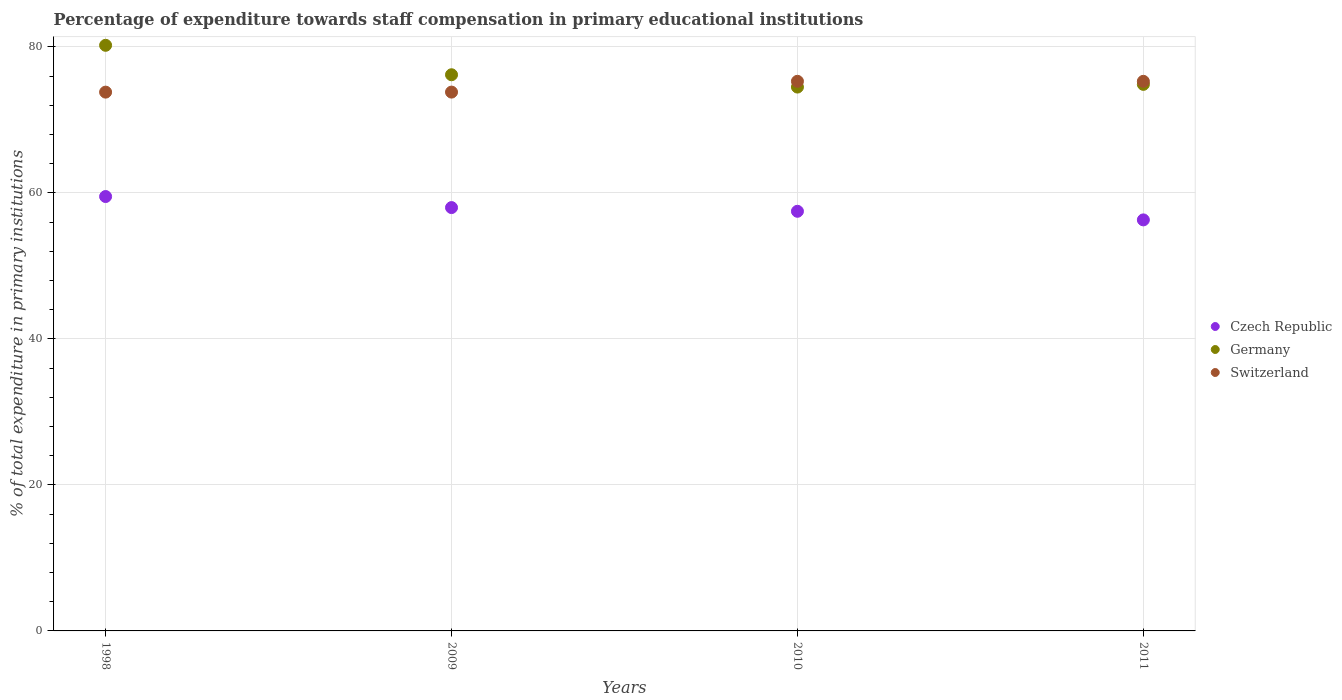What is the percentage of expenditure towards staff compensation in Czech Republic in 2009?
Your response must be concise. 57.99. Across all years, what is the maximum percentage of expenditure towards staff compensation in Czech Republic?
Your answer should be very brief. 59.51. Across all years, what is the minimum percentage of expenditure towards staff compensation in Germany?
Your answer should be very brief. 74.5. In which year was the percentage of expenditure towards staff compensation in Germany minimum?
Your answer should be very brief. 2010. What is the total percentage of expenditure towards staff compensation in Germany in the graph?
Offer a terse response. 305.79. What is the difference between the percentage of expenditure towards staff compensation in Switzerland in 1998 and that in 2011?
Provide a succinct answer. -1.48. What is the difference between the percentage of expenditure towards staff compensation in Czech Republic in 2011 and the percentage of expenditure towards staff compensation in Germany in 2009?
Your answer should be compact. -19.88. What is the average percentage of expenditure towards staff compensation in Czech Republic per year?
Give a very brief answer. 57.82. In the year 2011, what is the difference between the percentage of expenditure towards staff compensation in Czech Republic and percentage of expenditure towards staff compensation in Germany?
Offer a very short reply. -18.57. In how many years, is the percentage of expenditure towards staff compensation in Switzerland greater than 8 %?
Keep it short and to the point. 4. What is the ratio of the percentage of expenditure towards staff compensation in Czech Republic in 1998 to that in 2009?
Offer a very short reply. 1.03. Is the difference between the percentage of expenditure towards staff compensation in Czech Republic in 1998 and 2011 greater than the difference between the percentage of expenditure towards staff compensation in Germany in 1998 and 2011?
Offer a terse response. No. What is the difference between the highest and the second highest percentage of expenditure towards staff compensation in Germany?
Your answer should be very brief. 4.03. What is the difference between the highest and the lowest percentage of expenditure towards staff compensation in Czech Republic?
Give a very brief answer. 3.2. Is the percentage of expenditure towards staff compensation in Germany strictly less than the percentage of expenditure towards staff compensation in Czech Republic over the years?
Offer a terse response. No. How many dotlines are there?
Your response must be concise. 3. What is the difference between two consecutive major ticks on the Y-axis?
Offer a very short reply. 20. Are the values on the major ticks of Y-axis written in scientific E-notation?
Your answer should be very brief. No. Does the graph contain any zero values?
Ensure brevity in your answer.  No. How many legend labels are there?
Make the answer very short. 3. How are the legend labels stacked?
Your answer should be very brief. Vertical. What is the title of the graph?
Offer a terse response. Percentage of expenditure towards staff compensation in primary educational institutions. What is the label or title of the Y-axis?
Ensure brevity in your answer.  % of total expenditure in primary institutions. What is the % of total expenditure in primary institutions in Czech Republic in 1998?
Your response must be concise. 59.51. What is the % of total expenditure in primary institutions of Germany in 1998?
Provide a short and direct response. 80.22. What is the % of total expenditure in primary institutions of Switzerland in 1998?
Give a very brief answer. 73.81. What is the % of total expenditure in primary institutions of Czech Republic in 2009?
Ensure brevity in your answer.  57.99. What is the % of total expenditure in primary institutions of Germany in 2009?
Offer a terse response. 76.19. What is the % of total expenditure in primary institutions in Switzerland in 2009?
Give a very brief answer. 73.81. What is the % of total expenditure in primary institutions in Czech Republic in 2010?
Offer a very short reply. 57.49. What is the % of total expenditure in primary institutions in Germany in 2010?
Keep it short and to the point. 74.5. What is the % of total expenditure in primary institutions of Switzerland in 2010?
Offer a terse response. 75.29. What is the % of total expenditure in primary institutions of Czech Republic in 2011?
Make the answer very short. 56.31. What is the % of total expenditure in primary institutions in Germany in 2011?
Provide a short and direct response. 74.87. What is the % of total expenditure in primary institutions in Switzerland in 2011?
Your answer should be very brief. 75.29. Across all years, what is the maximum % of total expenditure in primary institutions of Czech Republic?
Keep it short and to the point. 59.51. Across all years, what is the maximum % of total expenditure in primary institutions of Germany?
Your answer should be compact. 80.22. Across all years, what is the maximum % of total expenditure in primary institutions of Switzerland?
Offer a very short reply. 75.29. Across all years, what is the minimum % of total expenditure in primary institutions in Czech Republic?
Offer a terse response. 56.31. Across all years, what is the minimum % of total expenditure in primary institutions in Germany?
Make the answer very short. 74.5. Across all years, what is the minimum % of total expenditure in primary institutions of Switzerland?
Provide a short and direct response. 73.81. What is the total % of total expenditure in primary institutions in Czech Republic in the graph?
Your answer should be compact. 231.29. What is the total % of total expenditure in primary institutions in Germany in the graph?
Your answer should be compact. 305.79. What is the total % of total expenditure in primary institutions of Switzerland in the graph?
Your answer should be very brief. 298.2. What is the difference between the % of total expenditure in primary institutions in Czech Republic in 1998 and that in 2009?
Provide a succinct answer. 1.51. What is the difference between the % of total expenditure in primary institutions in Germany in 1998 and that in 2009?
Your answer should be very brief. 4.03. What is the difference between the % of total expenditure in primary institutions of Switzerland in 1998 and that in 2009?
Your answer should be compact. -0. What is the difference between the % of total expenditure in primary institutions of Czech Republic in 1998 and that in 2010?
Your response must be concise. 2.02. What is the difference between the % of total expenditure in primary institutions of Germany in 1998 and that in 2010?
Give a very brief answer. 5.72. What is the difference between the % of total expenditure in primary institutions in Switzerland in 1998 and that in 2010?
Give a very brief answer. -1.48. What is the difference between the % of total expenditure in primary institutions of Czech Republic in 1998 and that in 2011?
Your answer should be very brief. 3.2. What is the difference between the % of total expenditure in primary institutions of Germany in 1998 and that in 2011?
Offer a terse response. 5.35. What is the difference between the % of total expenditure in primary institutions of Switzerland in 1998 and that in 2011?
Make the answer very short. -1.48. What is the difference between the % of total expenditure in primary institutions of Czech Republic in 2009 and that in 2010?
Your answer should be very brief. 0.51. What is the difference between the % of total expenditure in primary institutions in Germany in 2009 and that in 2010?
Provide a succinct answer. 1.69. What is the difference between the % of total expenditure in primary institutions of Switzerland in 2009 and that in 2010?
Give a very brief answer. -1.48. What is the difference between the % of total expenditure in primary institutions of Czech Republic in 2009 and that in 2011?
Give a very brief answer. 1.69. What is the difference between the % of total expenditure in primary institutions of Germany in 2009 and that in 2011?
Provide a succinct answer. 1.32. What is the difference between the % of total expenditure in primary institutions of Switzerland in 2009 and that in 2011?
Offer a terse response. -1.48. What is the difference between the % of total expenditure in primary institutions in Czech Republic in 2010 and that in 2011?
Your response must be concise. 1.18. What is the difference between the % of total expenditure in primary institutions in Germany in 2010 and that in 2011?
Offer a terse response. -0.37. What is the difference between the % of total expenditure in primary institutions of Switzerland in 2010 and that in 2011?
Your answer should be very brief. 0. What is the difference between the % of total expenditure in primary institutions in Czech Republic in 1998 and the % of total expenditure in primary institutions in Germany in 2009?
Keep it short and to the point. -16.68. What is the difference between the % of total expenditure in primary institutions of Czech Republic in 1998 and the % of total expenditure in primary institutions of Switzerland in 2009?
Keep it short and to the point. -14.31. What is the difference between the % of total expenditure in primary institutions in Germany in 1998 and the % of total expenditure in primary institutions in Switzerland in 2009?
Your answer should be very brief. 6.41. What is the difference between the % of total expenditure in primary institutions of Czech Republic in 1998 and the % of total expenditure in primary institutions of Germany in 2010?
Keep it short and to the point. -15. What is the difference between the % of total expenditure in primary institutions of Czech Republic in 1998 and the % of total expenditure in primary institutions of Switzerland in 2010?
Offer a very short reply. -15.79. What is the difference between the % of total expenditure in primary institutions in Germany in 1998 and the % of total expenditure in primary institutions in Switzerland in 2010?
Your response must be concise. 4.93. What is the difference between the % of total expenditure in primary institutions of Czech Republic in 1998 and the % of total expenditure in primary institutions of Germany in 2011?
Ensure brevity in your answer.  -15.37. What is the difference between the % of total expenditure in primary institutions in Czech Republic in 1998 and the % of total expenditure in primary institutions in Switzerland in 2011?
Your response must be concise. -15.78. What is the difference between the % of total expenditure in primary institutions of Germany in 1998 and the % of total expenditure in primary institutions of Switzerland in 2011?
Your answer should be compact. 4.94. What is the difference between the % of total expenditure in primary institutions in Czech Republic in 2009 and the % of total expenditure in primary institutions in Germany in 2010?
Offer a terse response. -16.51. What is the difference between the % of total expenditure in primary institutions in Czech Republic in 2009 and the % of total expenditure in primary institutions in Switzerland in 2010?
Offer a very short reply. -17.3. What is the difference between the % of total expenditure in primary institutions in Germany in 2009 and the % of total expenditure in primary institutions in Switzerland in 2010?
Your answer should be very brief. 0.9. What is the difference between the % of total expenditure in primary institutions of Czech Republic in 2009 and the % of total expenditure in primary institutions of Germany in 2011?
Give a very brief answer. -16.88. What is the difference between the % of total expenditure in primary institutions in Czech Republic in 2009 and the % of total expenditure in primary institutions in Switzerland in 2011?
Ensure brevity in your answer.  -17.29. What is the difference between the % of total expenditure in primary institutions in Germany in 2009 and the % of total expenditure in primary institutions in Switzerland in 2011?
Ensure brevity in your answer.  0.9. What is the difference between the % of total expenditure in primary institutions in Czech Republic in 2010 and the % of total expenditure in primary institutions in Germany in 2011?
Provide a short and direct response. -17.39. What is the difference between the % of total expenditure in primary institutions of Czech Republic in 2010 and the % of total expenditure in primary institutions of Switzerland in 2011?
Provide a short and direct response. -17.8. What is the difference between the % of total expenditure in primary institutions in Germany in 2010 and the % of total expenditure in primary institutions in Switzerland in 2011?
Give a very brief answer. -0.79. What is the average % of total expenditure in primary institutions of Czech Republic per year?
Your answer should be compact. 57.82. What is the average % of total expenditure in primary institutions of Germany per year?
Keep it short and to the point. 76.45. What is the average % of total expenditure in primary institutions in Switzerland per year?
Make the answer very short. 74.55. In the year 1998, what is the difference between the % of total expenditure in primary institutions of Czech Republic and % of total expenditure in primary institutions of Germany?
Provide a succinct answer. -20.72. In the year 1998, what is the difference between the % of total expenditure in primary institutions of Czech Republic and % of total expenditure in primary institutions of Switzerland?
Provide a succinct answer. -14.3. In the year 1998, what is the difference between the % of total expenditure in primary institutions in Germany and % of total expenditure in primary institutions in Switzerland?
Your answer should be very brief. 6.41. In the year 2009, what is the difference between the % of total expenditure in primary institutions of Czech Republic and % of total expenditure in primary institutions of Germany?
Keep it short and to the point. -18.2. In the year 2009, what is the difference between the % of total expenditure in primary institutions of Czech Republic and % of total expenditure in primary institutions of Switzerland?
Provide a short and direct response. -15.82. In the year 2009, what is the difference between the % of total expenditure in primary institutions in Germany and % of total expenditure in primary institutions in Switzerland?
Provide a short and direct response. 2.38. In the year 2010, what is the difference between the % of total expenditure in primary institutions in Czech Republic and % of total expenditure in primary institutions in Germany?
Provide a succinct answer. -17.02. In the year 2010, what is the difference between the % of total expenditure in primary institutions in Czech Republic and % of total expenditure in primary institutions in Switzerland?
Keep it short and to the point. -17.81. In the year 2010, what is the difference between the % of total expenditure in primary institutions of Germany and % of total expenditure in primary institutions of Switzerland?
Offer a terse response. -0.79. In the year 2011, what is the difference between the % of total expenditure in primary institutions in Czech Republic and % of total expenditure in primary institutions in Germany?
Offer a terse response. -18.57. In the year 2011, what is the difference between the % of total expenditure in primary institutions in Czech Republic and % of total expenditure in primary institutions in Switzerland?
Make the answer very short. -18.98. In the year 2011, what is the difference between the % of total expenditure in primary institutions of Germany and % of total expenditure in primary institutions of Switzerland?
Make the answer very short. -0.41. What is the ratio of the % of total expenditure in primary institutions in Czech Republic in 1998 to that in 2009?
Your answer should be very brief. 1.03. What is the ratio of the % of total expenditure in primary institutions in Germany in 1998 to that in 2009?
Offer a terse response. 1.05. What is the ratio of the % of total expenditure in primary institutions in Czech Republic in 1998 to that in 2010?
Provide a succinct answer. 1.04. What is the ratio of the % of total expenditure in primary institutions in Germany in 1998 to that in 2010?
Ensure brevity in your answer.  1.08. What is the ratio of the % of total expenditure in primary institutions of Switzerland in 1998 to that in 2010?
Make the answer very short. 0.98. What is the ratio of the % of total expenditure in primary institutions of Czech Republic in 1998 to that in 2011?
Ensure brevity in your answer.  1.06. What is the ratio of the % of total expenditure in primary institutions of Germany in 1998 to that in 2011?
Provide a short and direct response. 1.07. What is the ratio of the % of total expenditure in primary institutions of Switzerland in 1998 to that in 2011?
Your answer should be very brief. 0.98. What is the ratio of the % of total expenditure in primary institutions in Czech Republic in 2009 to that in 2010?
Give a very brief answer. 1.01. What is the ratio of the % of total expenditure in primary institutions of Germany in 2009 to that in 2010?
Your answer should be compact. 1.02. What is the ratio of the % of total expenditure in primary institutions of Switzerland in 2009 to that in 2010?
Provide a succinct answer. 0.98. What is the ratio of the % of total expenditure in primary institutions of Czech Republic in 2009 to that in 2011?
Your response must be concise. 1.03. What is the ratio of the % of total expenditure in primary institutions in Germany in 2009 to that in 2011?
Keep it short and to the point. 1.02. What is the ratio of the % of total expenditure in primary institutions of Switzerland in 2009 to that in 2011?
Provide a succinct answer. 0.98. What is the ratio of the % of total expenditure in primary institutions in Czech Republic in 2010 to that in 2011?
Ensure brevity in your answer.  1.02. What is the ratio of the % of total expenditure in primary institutions in Germany in 2010 to that in 2011?
Provide a short and direct response. 0.99. What is the ratio of the % of total expenditure in primary institutions of Switzerland in 2010 to that in 2011?
Provide a succinct answer. 1. What is the difference between the highest and the second highest % of total expenditure in primary institutions in Czech Republic?
Provide a short and direct response. 1.51. What is the difference between the highest and the second highest % of total expenditure in primary institutions of Germany?
Provide a succinct answer. 4.03. What is the difference between the highest and the second highest % of total expenditure in primary institutions in Switzerland?
Your answer should be compact. 0. What is the difference between the highest and the lowest % of total expenditure in primary institutions of Germany?
Ensure brevity in your answer.  5.72. What is the difference between the highest and the lowest % of total expenditure in primary institutions of Switzerland?
Provide a succinct answer. 1.48. 